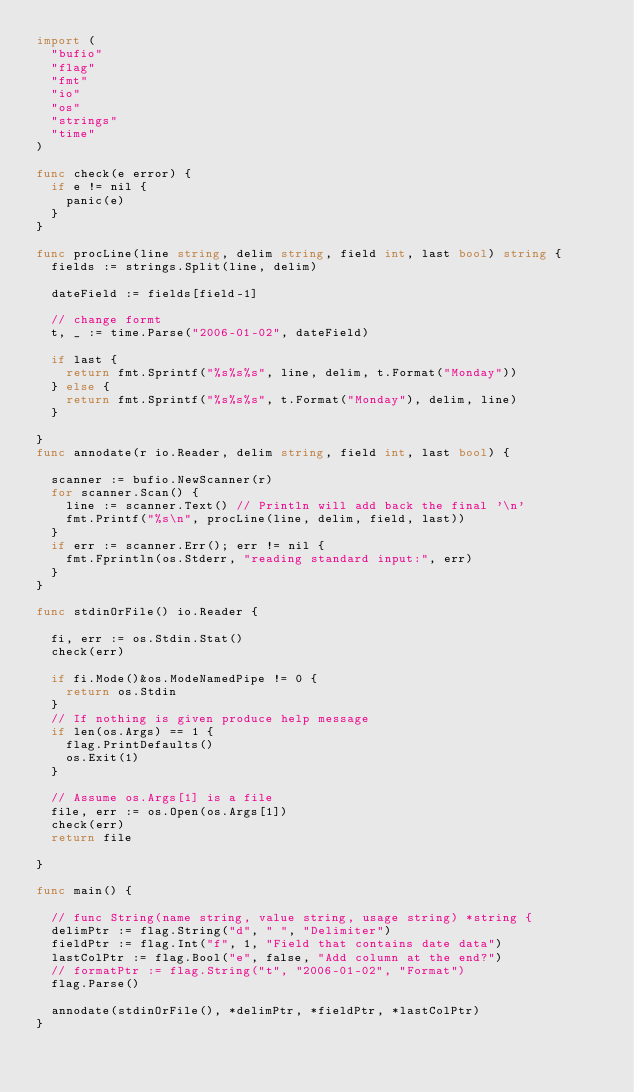Convert code to text. <code><loc_0><loc_0><loc_500><loc_500><_Go_>import (
	"bufio"
	"flag"
	"fmt"
	"io"
	"os"
	"strings"
	"time"
)

func check(e error) {
	if e != nil {
		panic(e)
	}
}

func procLine(line string, delim string, field int, last bool) string {
	fields := strings.Split(line, delim)

	dateField := fields[field-1]

	// change formt
	t, _ := time.Parse("2006-01-02", dateField)

	if last {
		return fmt.Sprintf("%s%s%s", line, delim, t.Format("Monday"))
	} else {
		return fmt.Sprintf("%s%s%s", t.Format("Monday"), delim, line)
	}

}
func annodate(r io.Reader, delim string, field int, last bool) {

	scanner := bufio.NewScanner(r)
	for scanner.Scan() {
		line := scanner.Text() // Println will add back the final '\n'
		fmt.Printf("%s\n", procLine(line, delim, field, last))
	}
	if err := scanner.Err(); err != nil {
		fmt.Fprintln(os.Stderr, "reading standard input:", err)
	}
}

func stdinOrFile() io.Reader {

	fi, err := os.Stdin.Stat()
	check(err)

	if fi.Mode()&os.ModeNamedPipe != 0 {
		return os.Stdin
	}
	// If nothing is given produce help message
	if len(os.Args) == 1 {
		flag.PrintDefaults()
		os.Exit(1)
	}

	// Assume os.Args[1] is a file
	file, err := os.Open(os.Args[1])
	check(err)
	return file

}

func main() {

	// func String(name string, value string, usage string) *string {
	delimPtr := flag.String("d", " ", "Delimiter")
	fieldPtr := flag.Int("f", 1, "Field that contains date data")
	lastColPtr := flag.Bool("e", false, "Add column at the end?")
	// formatPtr := flag.String("t", "2006-01-02", "Format")
	flag.Parse()

	annodate(stdinOrFile(), *delimPtr, *fieldPtr, *lastColPtr)
}
</code> 